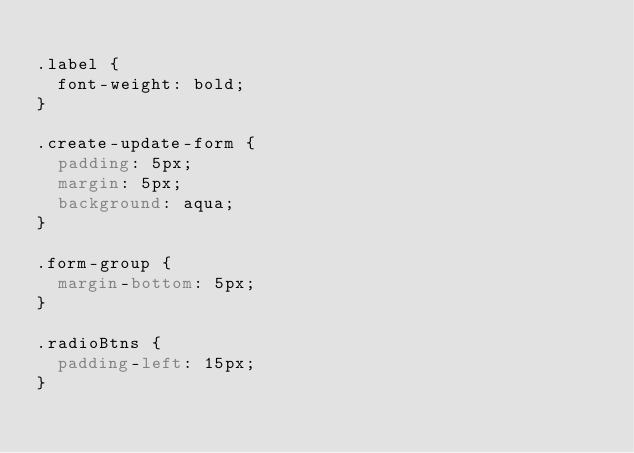Convert code to text. <code><loc_0><loc_0><loc_500><loc_500><_CSS_>
.label {
  font-weight: bold;
}

.create-update-form {
  padding: 5px;
  margin: 5px;
  background: aqua;
}

.form-group {
  margin-bottom: 5px;
}

.radioBtns {
  padding-left: 15px;
}</code> 